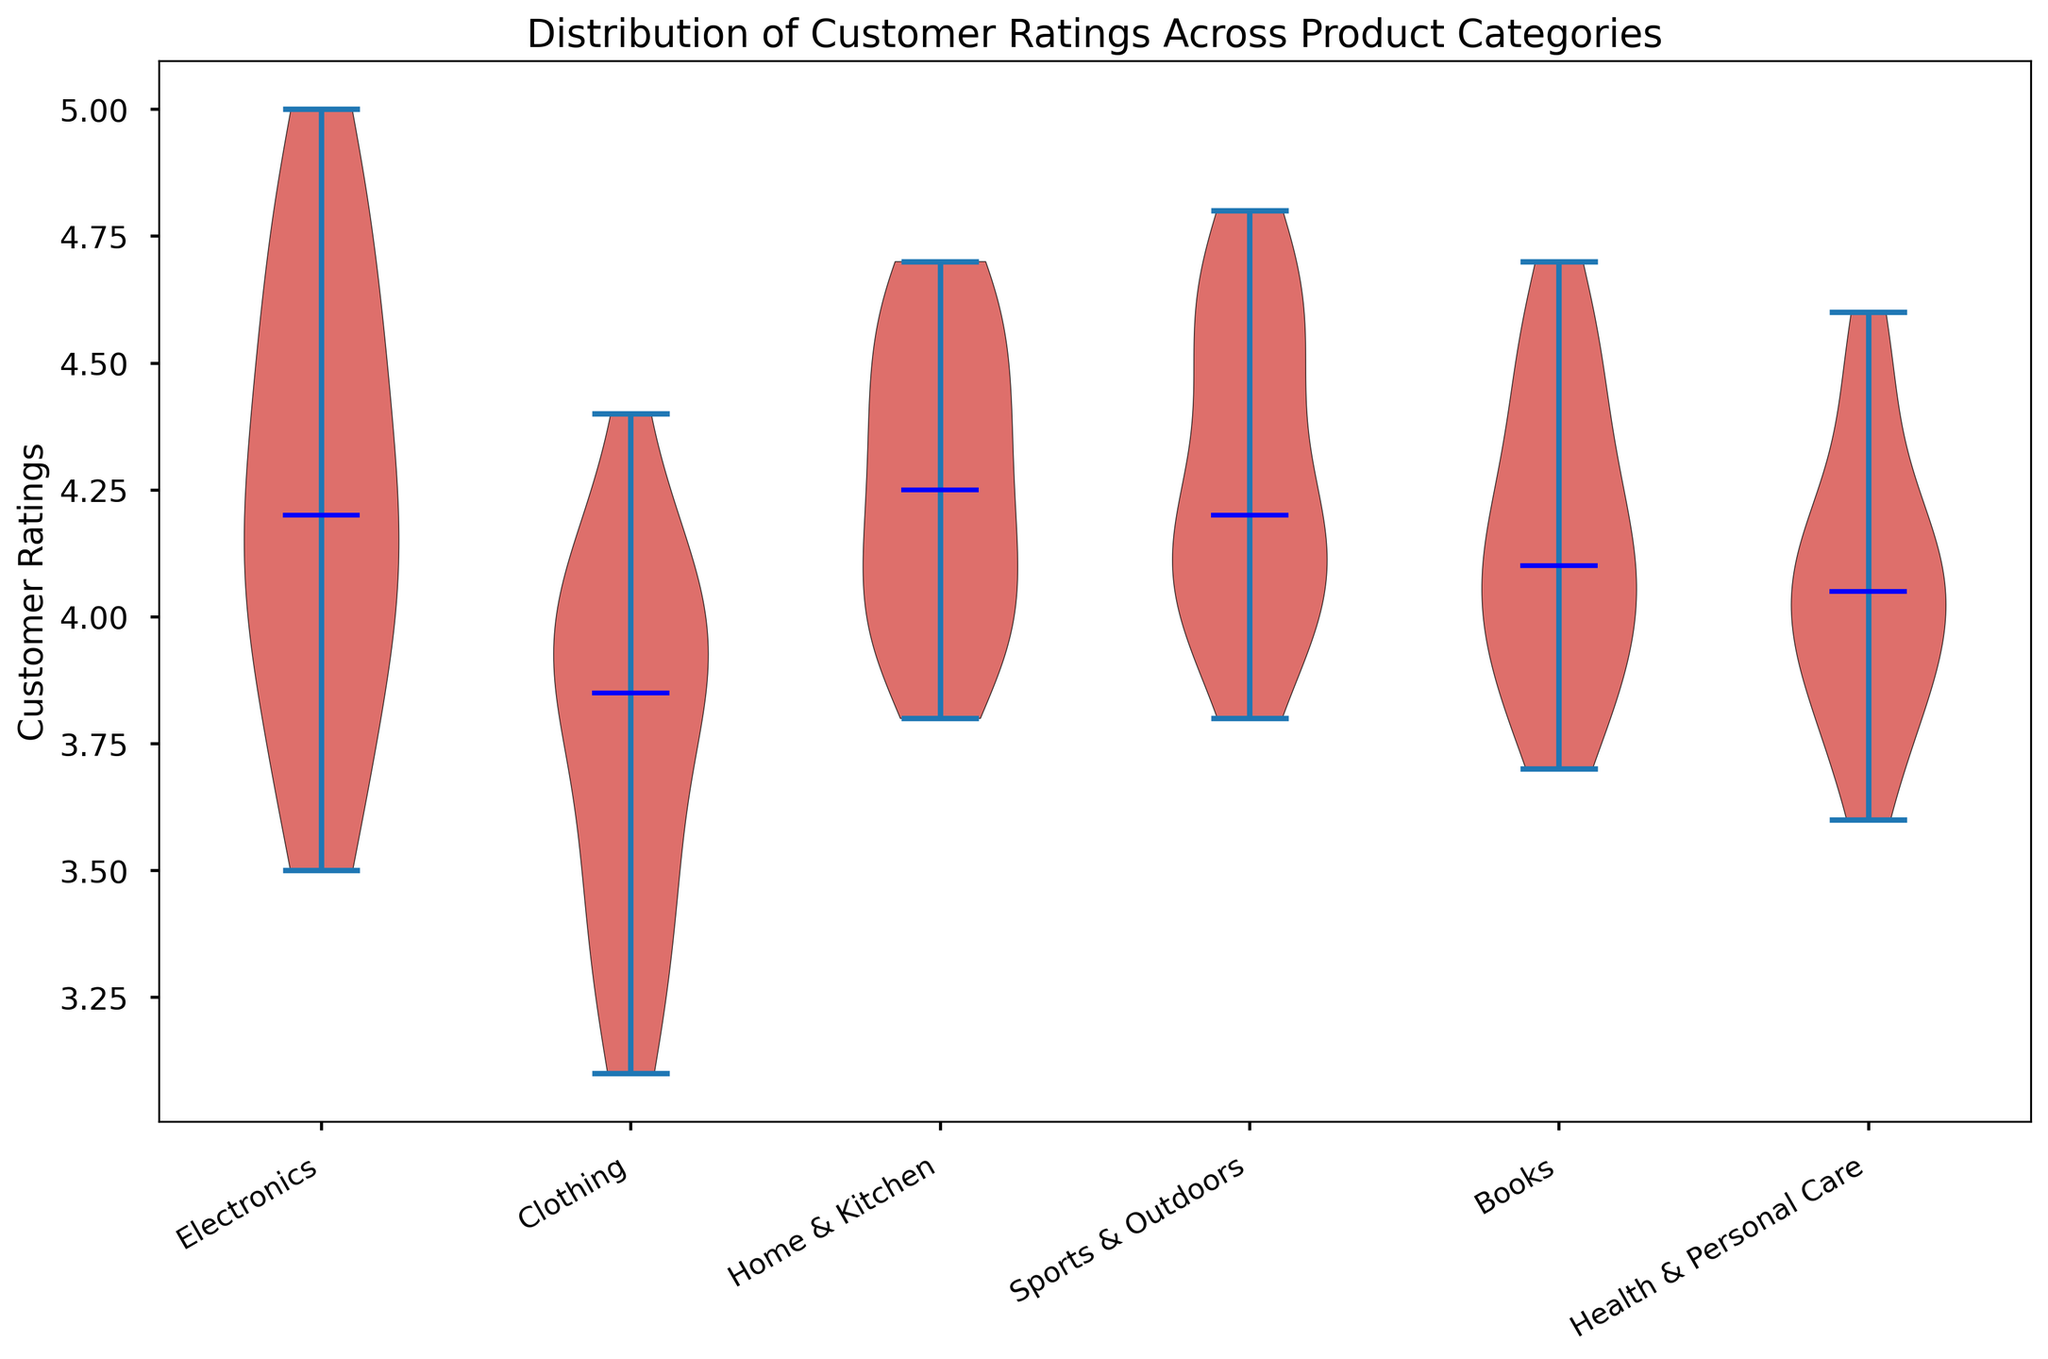What is the median customer rating for the Electronics category? The violin plot shows a blue line indicating the median value within the distribution of customer ratings for each category. For the Electronics category, the blue line is around the 4.1 mark.
Answer: 4.1 Which product category has the highest median customer rating? By examining the blue median lines for each category in the violin plot, the highest median line appears under Sports & Outdoors, indicating it has the highest median customer rating.
Answer: Sports & Outdoors How do the customer ratings for Clothing compare to those for Electronics? Visually comparing the spread and central tendencies (medians) of the violin plots, Clothing has a broader spread of lower ratings compared to Electronics, whose distribution is more concentrated around higher ratings. The median rating for Clothing is lower than that for Electronics.
Answer: Clothing has lower ratings For which category is the distribution of customer ratings the most spread out? By examining the width of the violin plots, the category with the widest plot indicates the most spread distribution of ratings. Clothing appears to have the widest spread of ratings.
Answer: Clothing Is the median customer rating for Books higher or lower than the median for Health & Personal Care? Compare the blue median lines for both Books and Health & Personal Care. The median for Books is higher, positioned around 4.1 compared to about 4.0 for Health & Personal Care.
Answer: Higher for Books Which category shows the least variation in customer ratings? The category with the narrowest and least spread out violin plot shows the least variation. Both Electronics and Books have relatively narrow plots, signaling less variation in ratings.
Answer: Electronics or Books What is the approximate range of customer ratings for Home & Kitchen? Looking at the vertical span of the Home & Kitchen violin plot, the ratings range from about 3.8 to 4.7.
Answer: 3.8 to 4.7 Which product category has the most ratings above 4.5? The side peaks (density) suggest the spread of data points above 4.5. The Sports & Outdoors and Home & Kitchen categories both show significant density above 4.5.
Answer: Sports & Outdoors and Home & Kitchen Are there any product categories with customer ratings below 3.5? By visually examining the lower bound of each violin plot, Clothing is the category with some ratings dipping below 3.5.
Answer: Clothing 